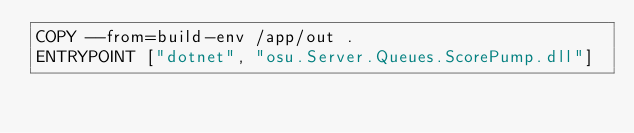<code> <loc_0><loc_0><loc_500><loc_500><_Dockerfile_>COPY --from=build-env /app/out .
ENTRYPOINT ["dotnet", "osu.Server.Queues.ScorePump.dll"]
</code> 